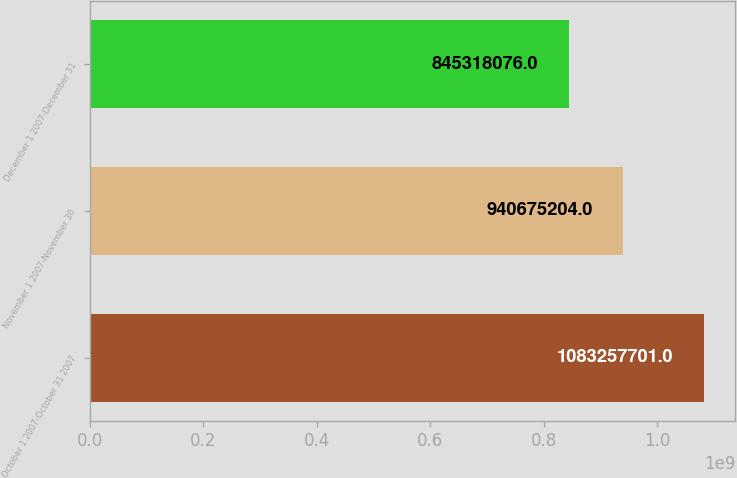Convert chart. <chart><loc_0><loc_0><loc_500><loc_500><bar_chart><fcel>October 1 2007-October 31 2007<fcel>November 1 2007-November 30<fcel>December 1 2007-December 31<nl><fcel>1.08326e+09<fcel>9.40675e+08<fcel>8.45318e+08<nl></chart> 